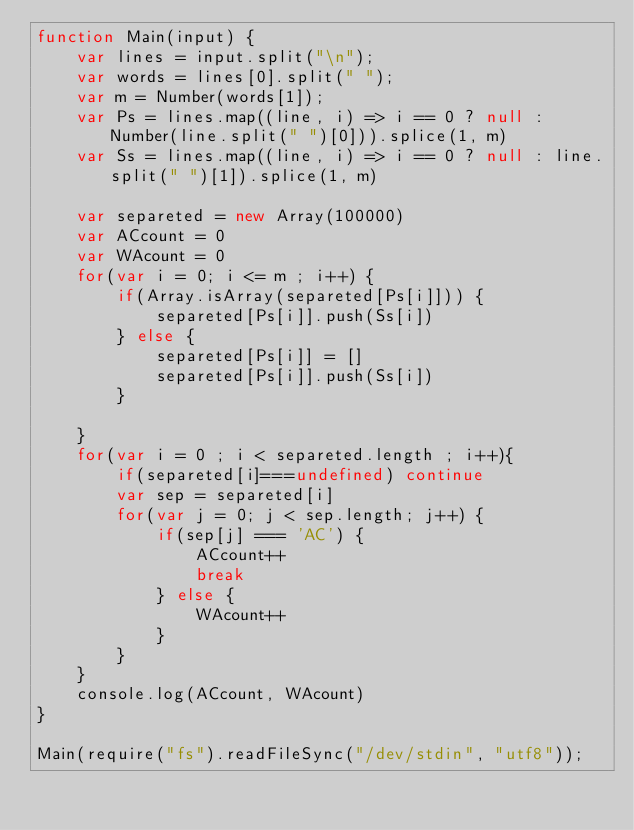<code> <loc_0><loc_0><loc_500><loc_500><_JavaScript_>function Main(input) {
	var lines = input.split("\n");
	var words = lines[0].split(" ");
	var m = Number(words[1]);
	var Ps = lines.map((line, i) => i == 0 ? null : Number(line.split(" ")[0])).splice(1, m)
	var Ss = lines.map((line, i) => i == 0 ? null : line.split(" ")[1]).splice(1, m)

	var separeted = new Array(100000)
	var ACcount = 0
	var WAcount = 0
	for(var i = 0; i <= m ; i++) {
		if(Array.isArray(separeted[Ps[i]])) {
			separeted[Ps[i]].push(Ss[i])
		} else {
			separeted[Ps[i]] = []
			separeted[Ps[i]].push(Ss[i])
		}
		
	}
	for(var i = 0 ; i < separeted.length ; i++){
		if(separeted[i]===undefined) continue
		var sep = separeted[i]
		for(var j = 0; j < sep.length; j++) {
			if(sep[j] === 'AC') {
				ACcount++
				break
			} else {
				WAcount++
			}
		}
	}
	console.log(ACcount, WAcount)
}

Main(require("fs").readFileSync("/dev/stdin", "utf8"));</code> 